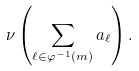<formula> <loc_0><loc_0><loc_500><loc_500>\nu \left ( \sum _ { \ell \in \varphi ^ { - 1 } ( m ) } a _ { \ell } \right ) .</formula> 